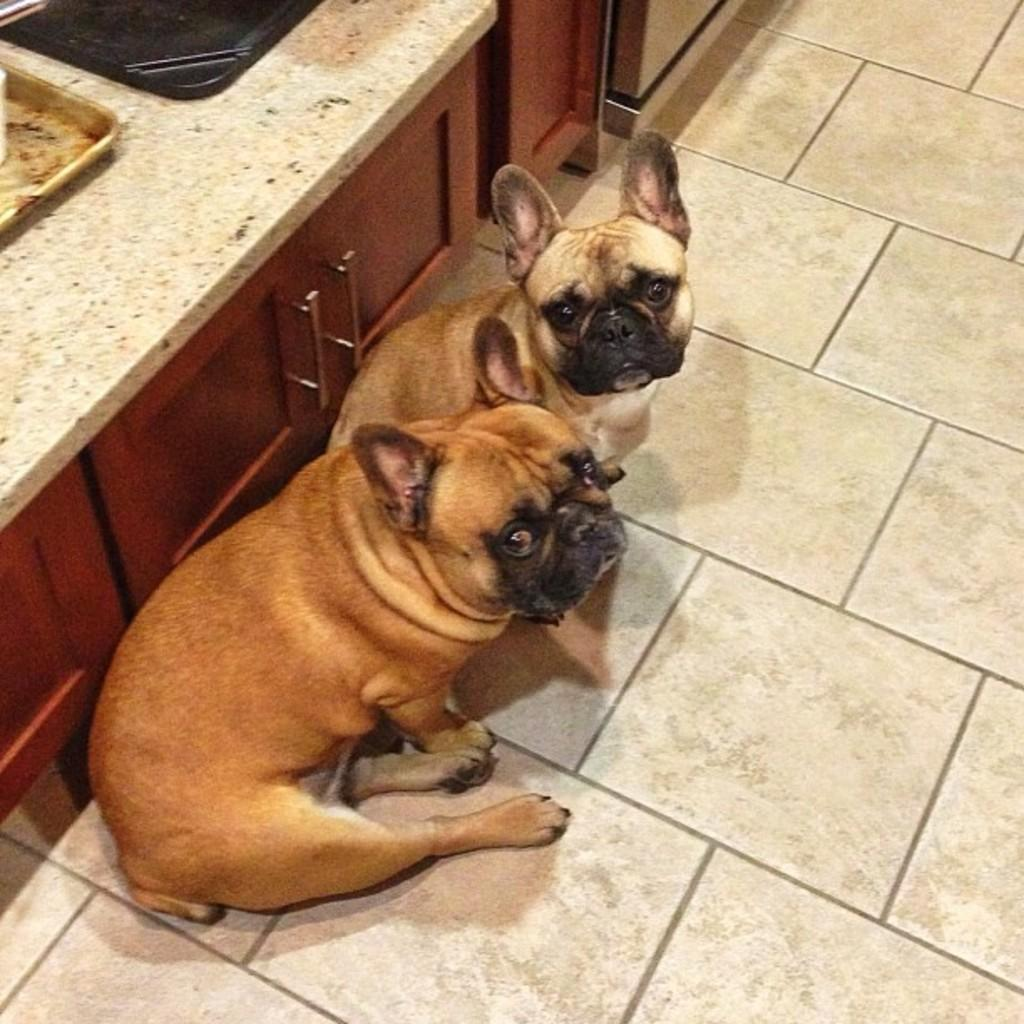How many dogs are in the image? There are two dogs in the image. Where are the dogs located? The dogs are on the floor. What can be seen in the background of the image? There are cupboards in the background of the image. What objects are on the cupboards? There are trays on the cabinet in the background of the image. What type of van is parked outside the window in the image? There is no van or window present in the image; it only features two dogs on the floor and cupboards in the background. 